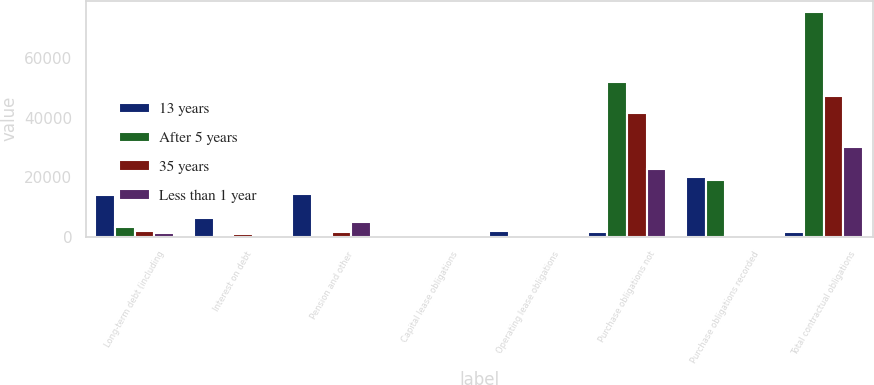Convert chart. <chart><loc_0><loc_0><loc_500><loc_500><stacked_bar_chart><ecel><fcel>Long-term debt (including<fcel>Interest on debt<fcel>Pension and other<fcel>Capital lease obligations<fcel>Operating lease obligations<fcel>Purchase obligations not<fcel>Purchase obligations recorded<fcel>Total contractual obligations<nl><fcel>13 years<fcel>13932<fcel>6458<fcel>14379<fcel>164<fcel>1850<fcel>1738.5<fcel>19900<fcel>1738.5<nl><fcel>After 5 years<fcel>3137<fcel>523<fcel>606<fcel>58<fcel>278<fcel>51784<fcel>19076<fcel>75462<nl><fcel>35 years<fcel>1927<fcel>891<fcel>1627<fcel>75<fcel>432<fcel>41470<fcel>716<fcel>47138<nl><fcel>Less than 1 year<fcel>1326<fcel>752<fcel>5050<fcel>20<fcel>291<fcel>22649<fcel>80<fcel>30168<nl></chart> 